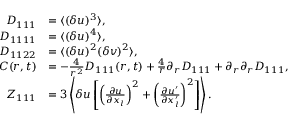Convert formula to latex. <formula><loc_0><loc_0><loc_500><loc_500>\begin{array} { r l } { D _ { 1 1 1 } } & { = \langle { ( \delta u ) ^ { 3 } } \rangle , } \\ { D _ { 1 1 1 1 } } & { = \langle { ( \delta u ) ^ { 4 } } \rangle , } \\ { D _ { 1 1 2 2 } } & { = \langle { ( \delta u ) ^ { 2 } ( \delta v ) ^ { 2 } } \rangle , } \\ { C ( r , t ) } & { = - \frac { 4 } { r ^ { 2 } } D _ { 1 1 1 } ( r , t ) + \frac { 4 } { r } \partial _ { r } D _ { 1 1 1 } + \partial _ { r } \partial _ { r } D _ { 1 1 1 } , } \\ { Z _ { 1 1 1 } } & { = 3 \left \langle { \delta u \left [ \left ( \frac { \partial u } { \partial x _ { l } } \right ) ^ { 2 } + \left ( \frac { \partial u ^ { \prime } } { \partial x _ { l } ^ { \prime } } \right ) ^ { 2 } \right ] } \right \rangle . } \end{array}</formula> 